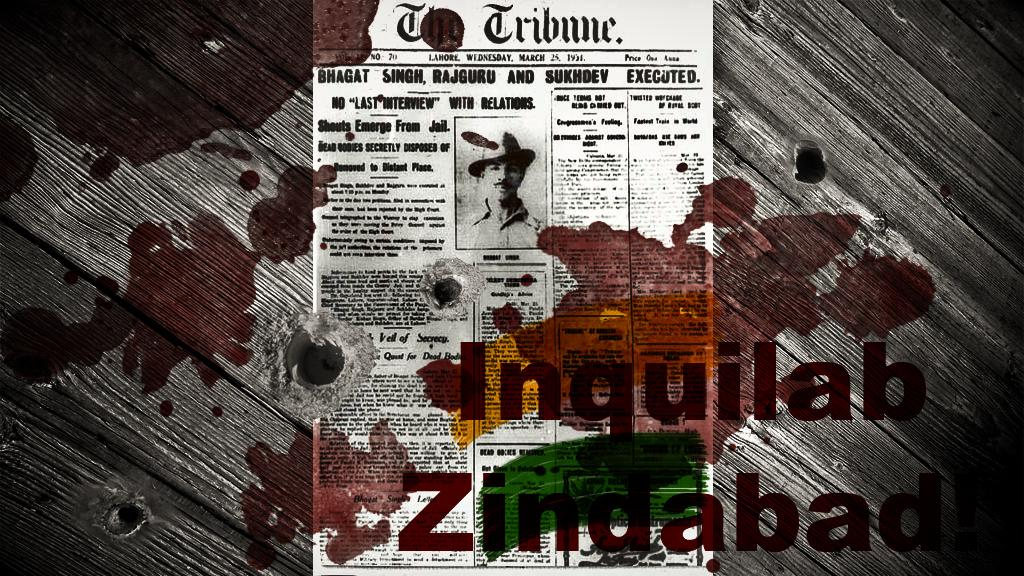<image>
Give a short and clear explanation of the subsequent image. The Tribune front page has a black and white photo of a man in a large hat. 